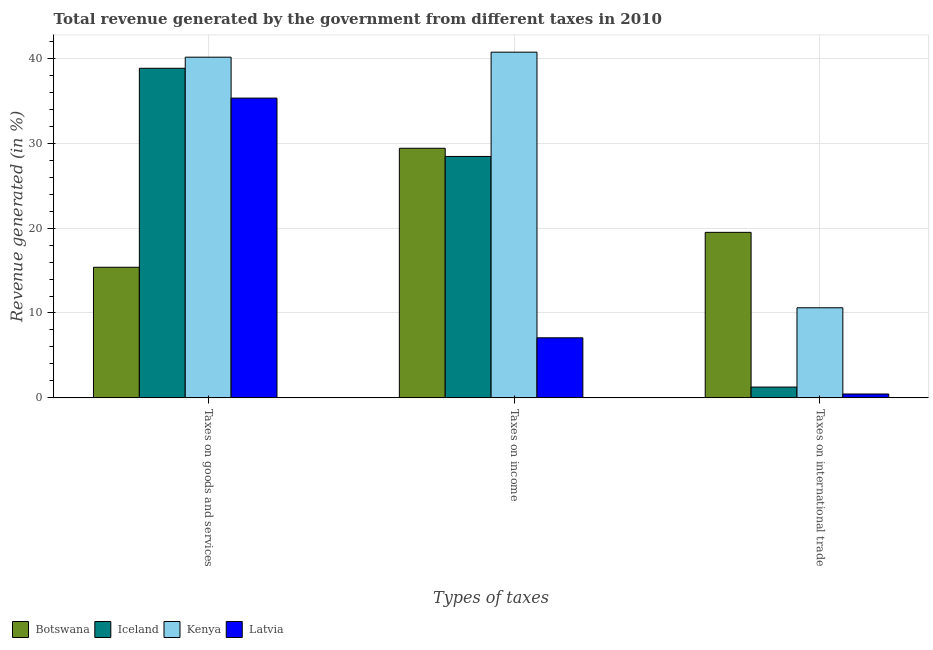How many groups of bars are there?
Your response must be concise. 3. Are the number of bars on each tick of the X-axis equal?
Your answer should be compact. Yes. How many bars are there on the 3rd tick from the right?
Make the answer very short. 4. What is the label of the 3rd group of bars from the left?
Your answer should be compact. Taxes on international trade. What is the percentage of revenue generated by taxes on goods and services in Latvia?
Provide a short and direct response. 35.32. Across all countries, what is the maximum percentage of revenue generated by taxes on income?
Provide a short and direct response. 40.73. Across all countries, what is the minimum percentage of revenue generated by taxes on income?
Offer a terse response. 7.08. In which country was the percentage of revenue generated by taxes on income maximum?
Your response must be concise. Kenya. In which country was the percentage of revenue generated by taxes on goods and services minimum?
Keep it short and to the point. Botswana. What is the total percentage of revenue generated by taxes on goods and services in the graph?
Your answer should be compact. 129.67. What is the difference between the percentage of revenue generated by taxes on income in Botswana and that in Kenya?
Your answer should be compact. -11.32. What is the difference between the percentage of revenue generated by taxes on income in Kenya and the percentage of revenue generated by taxes on goods and services in Botswana?
Give a very brief answer. 25.34. What is the average percentage of revenue generated by tax on international trade per country?
Give a very brief answer. 7.96. What is the difference between the percentage of revenue generated by tax on international trade and percentage of revenue generated by taxes on income in Iceland?
Keep it short and to the point. -27.17. In how many countries, is the percentage of revenue generated by tax on international trade greater than 22 %?
Offer a very short reply. 0. What is the ratio of the percentage of revenue generated by taxes on goods and services in Latvia to that in Botswana?
Ensure brevity in your answer.  2.3. Is the percentage of revenue generated by taxes on goods and services in Botswana less than that in Latvia?
Provide a succinct answer. Yes. Is the difference between the percentage of revenue generated by taxes on goods and services in Iceland and Latvia greater than the difference between the percentage of revenue generated by tax on international trade in Iceland and Latvia?
Keep it short and to the point. Yes. What is the difference between the highest and the second highest percentage of revenue generated by taxes on goods and services?
Your response must be concise. 1.31. What is the difference between the highest and the lowest percentage of revenue generated by tax on international trade?
Ensure brevity in your answer.  19.04. Is the sum of the percentage of revenue generated by taxes on income in Latvia and Botswana greater than the maximum percentage of revenue generated by tax on international trade across all countries?
Your response must be concise. Yes. What does the 2nd bar from the left in Taxes on goods and services represents?
Provide a short and direct response. Iceland. What does the 2nd bar from the right in Taxes on income represents?
Your answer should be very brief. Kenya. Is it the case that in every country, the sum of the percentage of revenue generated by taxes on goods and services and percentage of revenue generated by taxes on income is greater than the percentage of revenue generated by tax on international trade?
Ensure brevity in your answer.  Yes. How many countries are there in the graph?
Your answer should be compact. 4. What is the difference between two consecutive major ticks on the Y-axis?
Your response must be concise. 10. Does the graph contain any zero values?
Your answer should be very brief. No. How many legend labels are there?
Provide a short and direct response. 4. How are the legend labels stacked?
Ensure brevity in your answer.  Horizontal. What is the title of the graph?
Your answer should be very brief. Total revenue generated by the government from different taxes in 2010. What is the label or title of the X-axis?
Your answer should be compact. Types of taxes. What is the label or title of the Y-axis?
Ensure brevity in your answer.  Revenue generated (in %). What is the Revenue generated (in %) in Botswana in Taxes on goods and services?
Your answer should be very brief. 15.39. What is the Revenue generated (in %) in Iceland in Taxes on goods and services?
Your response must be concise. 38.83. What is the Revenue generated (in %) in Kenya in Taxes on goods and services?
Provide a short and direct response. 40.14. What is the Revenue generated (in %) in Latvia in Taxes on goods and services?
Your response must be concise. 35.32. What is the Revenue generated (in %) of Botswana in Taxes on income?
Your answer should be compact. 29.4. What is the Revenue generated (in %) in Iceland in Taxes on income?
Ensure brevity in your answer.  28.44. What is the Revenue generated (in %) of Kenya in Taxes on income?
Keep it short and to the point. 40.73. What is the Revenue generated (in %) in Latvia in Taxes on income?
Make the answer very short. 7.08. What is the Revenue generated (in %) of Botswana in Taxes on international trade?
Give a very brief answer. 19.5. What is the Revenue generated (in %) in Iceland in Taxes on international trade?
Give a very brief answer. 1.27. What is the Revenue generated (in %) in Kenya in Taxes on international trade?
Offer a terse response. 10.61. What is the Revenue generated (in %) in Latvia in Taxes on international trade?
Ensure brevity in your answer.  0.46. Across all Types of taxes, what is the maximum Revenue generated (in %) in Botswana?
Your answer should be compact. 29.4. Across all Types of taxes, what is the maximum Revenue generated (in %) of Iceland?
Ensure brevity in your answer.  38.83. Across all Types of taxes, what is the maximum Revenue generated (in %) in Kenya?
Offer a terse response. 40.73. Across all Types of taxes, what is the maximum Revenue generated (in %) in Latvia?
Provide a succinct answer. 35.32. Across all Types of taxes, what is the minimum Revenue generated (in %) of Botswana?
Give a very brief answer. 15.39. Across all Types of taxes, what is the minimum Revenue generated (in %) of Iceland?
Keep it short and to the point. 1.27. Across all Types of taxes, what is the minimum Revenue generated (in %) in Kenya?
Provide a succinct answer. 10.61. Across all Types of taxes, what is the minimum Revenue generated (in %) in Latvia?
Ensure brevity in your answer.  0.46. What is the total Revenue generated (in %) of Botswana in the graph?
Ensure brevity in your answer.  64.29. What is the total Revenue generated (in %) in Iceland in the graph?
Your answer should be very brief. 68.55. What is the total Revenue generated (in %) of Kenya in the graph?
Give a very brief answer. 91.48. What is the total Revenue generated (in %) of Latvia in the graph?
Your response must be concise. 42.85. What is the difference between the Revenue generated (in %) of Botswana in Taxes on goods and services and that in Taxes on income?
Offer a terse response. -14.02. What is the difference between the Revenue generated (in %) of Iceland in Taxes on goods and services and that in Taxes on income?
Make the answer very short. 10.39. What is the difference between the Revenue generated (in %) of Kenya in Taxes on goods and services and that in Taxes on income?
Your response must be concise. -0.59. What is the difference between the Revenue generated (in %) of Latvia in Taxes on goods and services and that in Taxes on income?
Your answer should be compact. 28.24. What is the difference between the Revenue generated (in %) of Botswana in Taxes on goods and services and that in Taxes on international trade?
Keep it short and to the point. -4.11. What is the difference between the Revenue generated (in %) in Iceland in Taxes on goods and services and that in Taxes on international trade?
Your response must be concise. 37.56. What is the difference between the Revenue generated (in %) in Kenya in Taxes on goods and services and that in Taxes on international trade?
Offer a terse response. 29.52. What is the difference between the Revenue generated (in %) in Latvia in Taxes on goods and services and that in Taxes on international trade?
Offer a terse response. 34.86. What is the difference between the Revenue generated (in %) in Botswana in Taxes on income and that in Taxes on international trade?
Keep it short and to the point. 9.91. What is the difference between the Revenue generated (in %) in Iceland in Taxes on income and that in Taxes on international trade?
Your answer should be compact. 27.17. What is the difference between the Revenue generated (in %) in Kenya in Taxes on income and that in Taxes on international trade?
Offer a terse response. 30.11. What is the difference between the Revenue generated (in %) of Latvia in Taxes on income and that in Taxes on international trade?
Keep it short and to the point. 6.62. What is the difference between the Revenue generated (in %) of Botswana in Taxes on goods and services and the Revenue generated (in %) of Iceland in Taxes on income?
Provide a succinct answer. -13.05. What is the difference between the Revenue generated (in %) of Botswana in Taxes on goods and services and the Revenue generated (in %) of Kenya in Taxes on income?
Your answer should be very brief. -25.34. What is the difference between the Revenue generated (in %) in Botswana in Taxes on goods and services and the Revenue generated (in %) in Latvia in Taxes on income?
Offer a very short reply. 8.31. What is the difference between the Revenue generated (in %) of Iceland in Taxes on goods and services and the Revenue generated (in %) of Kenya in Taxes on income?
Keep it short and to the point. -1.9. What is the difference between the Revenue generated (in %) of Iceland in Taxes on goods and services and the Revenue generated (in %) of Latvia in Taxes on income?
Offer a terse response. 31.75. What is the difference between the Revenue generated (in %) of Kenya in Taxes on goods and services and the Revenue generated (in %) of Latvia in Taxes on income?
Your answer should be compact. 33.06. What is the difference between the Revenue generated (in %) in Botswana in Taxes on goods and services and the Revenue generated (in %) in Iceland in Taxes on international trade?
Your answer should be compact. 14.11. What is the difference between the Revenue generated (in %) of Botswana in Taxes on goods and services and the Revenue generated (in %) of Kenya in Taxes on international trade?
Ensure brevity in your answer.  4.77. What is the difference between the Revenue generated (in %) of Botswana in Taxes on goods and services and the Revenue generated (in %) of Latvia in Taxes on international trade?
Ensure brevity in your answer.  14.93. What is the difference between the Revenue generated (in %) of Iceland in Taxes on goods and services and the Revenue generated (in %) of Kenya in Taxes on international trade?
Your response must be concise. 28.22. What is the difference between the Revenue generated (in %) of Iceland in Taxes on goods and services and the Revenue generated (in %) of Latvia in Taxes on international trade?
Provide a short and direct response. 38.37. What is the difference between the Revenue generated (in %) of Kenya in Taxes on goods and services and the Revenue generated (in %) of Latvia in Taxes on international trade?
Keep it short and to the point. 39.68. What is the difference between the Revenue generated (in %) of Botswana in Taxes on income and the Revenue generated (in %) of Iceland in Taxes on international trade?
Your response must be concise. 28.13. What is the difference between the Revenue generated (in %) of Botswana in Taxes on income and the Revenue generated (in %) of Kenya in Taxes on international trade?
Your answer should be very brief. 18.79. What is the difference between the Revenue generated (in %) of Botswana in Taxes on income and the Revenue generated (in %) of Latvia in Taxes on international trade?
Provide a short and direct response. 28.95. What is the difference between the Revenue generated (in %) of Iceland in Taxes on income and the Revenue generated (in %) of Kenya in Taxes on international trade?
Give a very brief answer. 17.83. What is the difference between the Revenue generated (in %) in Iceland in Taxes on income and the Revenue generated (in %) in Latvia in Taxes on international trade?
Provide a short and direct response. 27.98. What is the difference between the Revenue generated (in %) of Kenya in Taxes on income and the Revenue generated (in %) of Latvia in Taxes on international trade?
Give a very brief answer. 40.27. What is the average Revenue generated (in %) of Botswana per Types of taxes?
Your answer should be very brief. 21.43. What is the average Revenue generated (in %) of Iceland per Types of taxes?
Your answer should be compact. 22.85. What is the average Revenue generated (in %) in Kenya per Types of taxes?
Provide a succinct answer. 30.49. What is the average Revenue generated (in %) in Latvia per Types of taxes?
Give a very brief answer. 14.28. What is the difference between the Revenue generated (in %) in Botswana and Revenue generated (in %) in Iceland in Taxes on goods and services?
Provide a short and direct response. -23.44. What is the difference between the Revenue generated (in %) of Botswana and Revenue generated (in %) of Kenya in Taxes on goods and services?
Your response must be concise. -24.75. What is the difference between the Revenue generated (in %) in Botswana and Revenue generated (in %) in Latvia in Taxes on goods and services?
Ensure brevity in your answer.  -19.93. What is the difference between the Revenue generated (in %) of Iceland and Revenue generated (in %) of Kenya in Taxes on goods and services?
Your answer should be compact. -1.31. What is the difference between the Revenue generated (in %) in Iceland and Revenue generated (in %) in Latvia in Taxes on goods and services?
Offer a very short reply. 3.51. What is the difference between the Revenue generated (in %) of Kenya and Revenue generated (in %) of Latvia in Taxes on goods and services?
Keep it short and to the point. 4.82. What is the difference between the Revenue generated (in %) in Botswana and Revenue generated (in %) in Iceland in Taxes on income?
Offer a very short reply. 0.96. What is the difference between the Revenue generated (in %) of Botswana and Revenue generated (in %) of Kenya in Taxes on income?
Your response must be concise. -11.32. What is the difference between the Revenue generated (in %) in Botswana and Revenue generated (in %) in Latvia in Taxes on income?
Provide a short and direct response. 22.33. What is the difference between the Revenue generated (in %) in Iceland and Revenue generated (in %) in Kenya in Taxes on income?
Provide a short and direct response. -12.29. What is the difference between the Revenue generated (in %) in Iceland and Revenue generated (in %) in Latvia in Taxes on income?
Ensure brevity in your answer.  21.36. What is the difference between the Revenue generated (in %) in Kenya and Revenue generated (in %) in Latvia in Taxes on income?
Your response must be concise. 33.65. What is the difference between the Revenue generated (in %) of Botswana and Revenue generated (in %) of Iceland in Taxes on international trade?
Give a very brief answer. 18.23. What is the difference between the Revenue generated (in %) of Botswana and Revenue generated (in %) of Kenya in Taxes on international trade?
Offer a terse response. 8.88. What is the difference between the Revenue generated (in %) in Botswana and Revenue generated (in %) in Latvia in Taxes on international trade?
Give a very brief answer. 19.04. What is the difference between the Revenue generated (in %) of Iceland and Revenue generated (in %) of Kenya in Taxes on international trade?
Offer a very short reply. -9.34. What is the difference between the Revenue generated (in %) of Iceland and Revenue generated (in %) of Latvia in Taxes on international trade?
Offer a terse response. 0.82. What is the difference between the Revenue generated (in %) in Kenya and Revenue generated (in %) in Latvia in Taxes on international trade?
Offer a very short reply. 10.16. What is the ratio of the Revenue generated (in %) of Botswana in Taxes on goods and services to that in Taxes on income?
Your response must be concise. 0.52. What is the ratio of the Revenue generated (in %) in Iceland in Taxes on goods and services to that in Taxes on income?
Provide a succinct answer. 1.37. What is the ratio of the Revenue generated (in %) of Kenya in Taxes on goods and services to that in Taxes on income?
Give a very brief answer. 0.99. What is the ratio of the Revenue generated (in %) of Latvia in Taxes on goods and services to that in Taxes on income?
Offer a very short reply. 4.99. What is the ratio of the Revenue generated (in %) of Botswana in Taxes on goods and services to that in Taxes on international trade?
Give a very brief answer. 0.79. What is the ratio of the Revenue generated (in %) of Iceland in Taxes on goods and services to that in Taxes on international trade?
Your response must be concise. 30.48. What is the ratio of the Revenue generated (in %) of Kenya in Taxes on goods and services to that in Taxes on international trade?
Provide a succinct answer. 3.78. What is the ratio of the Revenue generated (in %) in Latvia in Taxes on goods and services to that in Taxes on international trade?
Give a very brief answer. 77.38. What is the ratio of the Revenue generated (in %) of Botswana in Taxes on income to that in Taxes on international trade?
Provide a succinct answer. 1.51. What is the ratio of the Revenue generated (in %) in Iceland in Taxes on income to that in Taxes on international trade?
Provide a succinct answer. 22.32. What is the ratio of the Revenue generated (in %) of Kenya in Taxes on income to that in Taxes on international trade?
Ensure brevity in your answer.  3.84. What is the ratio of the Revenue generated (in %) in Latvia in Taxes on income to that in Taxes on international trade?
Your answer should be compact. 15.51. What is the difference between the highest and the second highest Revenue generated (in %) in Botswana?
Give a very brief answer. 9.91. What is the difference between the highest and the second highest Revenue generated (in %) in Iceland?
Ensure brevity in your answer.  10.39. What is the difference between the highest and the second highest Revenue generated (in %) in Kenya?
Offer a terse response. 0.59. What is the difference between the highest and the second highest Revenue generated (in %) in Latvia?
Give a very brief answer. 28.24. What is the difference between the highest and the lowest Revenue generated (in %) in Botswana?
Offer a terse response. 14.02. What is the difference between the highest and the lowest Revenue generated (in %) in Iceland?
Your answer should be very brief. 37.56. What is the difference between the highest and the lowest Revenue generated (in %) in Kenya?
Make the answer very short. 30.11. What is the difference between the highest and the lowest Revenue generated (in %) of Latvia?
Make the answer very short. 34.86. 